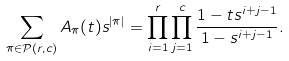Convert formula to latex. <formula><loc_0><loc_0><loc_500><loc_500>\sum _ { \pi \in \mathcal { P } ( r , c ) } A _ { \pi } ( t ) s ^ { | \pi | } = \prod _ { i = 1 } ^ { r } \prod _ { j = 1 } ^ { c } \frac { 1 - t s ^ { i + j - 1 } } { 1 - s ^ { i + j - 1 } } .</formula> 